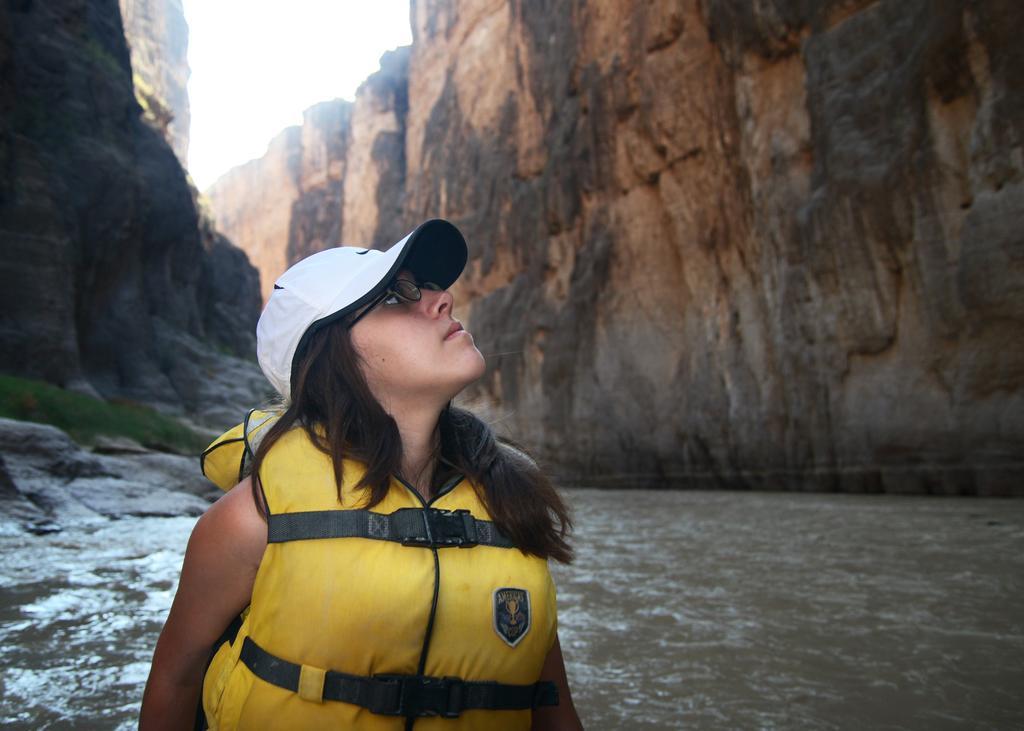Could you give a brief overview of what you see in this image? In the center of the image we can see a person is wearing jacket, spectacles, cap. In the background of the image we can see the rocks, grass, water. At the top of the image we can see the sky. 